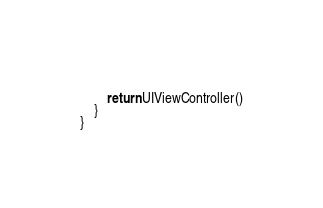Convert code to text. <code><loc_0><loc_0><loc_500><loc_500><_Swift_>            
        return UIViewController()
    }
}
</code> 